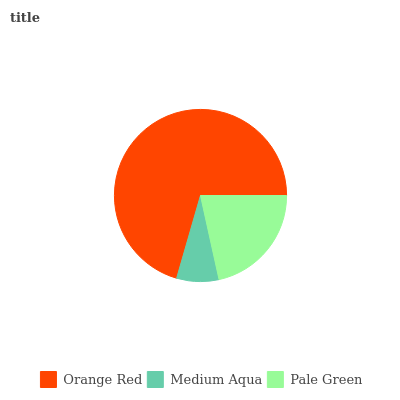Is Medium Aqua the minimum?
Answer yes or no. Yes. Is Orange Red the maximum?
Answer yes or no. Yes. Is Pale Green the minimum?
Answer yes or no. No. Is Pale Green the maximum?
Answer yes or no. No. Is Pale Green greater than Medium Aqua?
Answer yes or no. Yes. Is Medium Aqua less than Pale Green?
Answer yes or no. Yes. Is Medium Aqua greater than Pale Green?
Answer yes or no. No. Is Pale Green less than Medium Aqua?
Answer yes or no. No. Is Pale Green the high median?
Answer yes or no. Yes. Is Pale Green the low median?
Answer yes or no. Yes. Is Orange Red the high median?
Answer yes or no. No. Is Medium Aqua the low median?
Answer yes or no. No. 